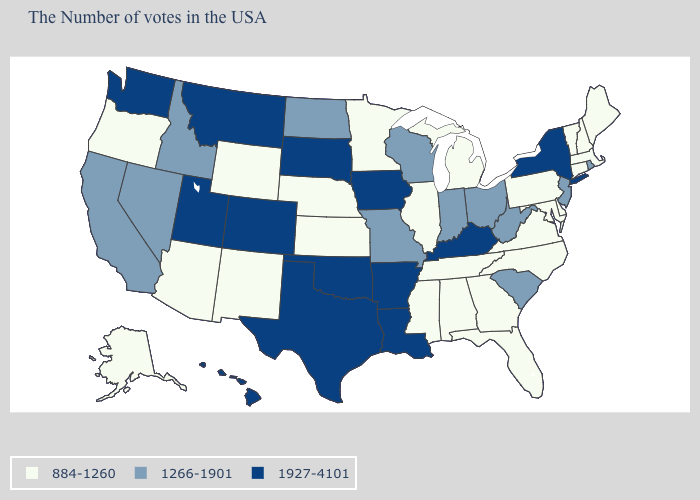Does New York have the lowest value in the Northeast?
Keep it brief. No. What is the value of Vermont?
Quick response, please. 884-1260. What is the value of Vermont?
Concise answer only. 884-1260. Is the legend a continuous bar?
Answer briefly. No. Among the states that border Nevada , which have the highest value?
Keep it brief. Utah. Which states have the highest value in the USA?
Keep it brief. New York, Kentucky, Louisiana, Arkansas, Iowa, Oklahoma, Texas, South Dakota, Colorado, Utah, Montana, Washington, Hawaii. What is the value of New Hampshire?
Quick response, please. 884-1260. Name the states that have a value in the range 1927-4101?
Write a very short answer. New York, Kentucky, Louisiana, Arkansas, Iowa, Oklahoma, Texas, South Dakota, Colorado, Utah, Montana, Washington, Hawaii. What is the value of Hawaii?
Short answer required. 1927-4101. Name the states that have a value in the range 884-1260?
Keep it brief. Maine, Massachusetts, New Hampshire, Vermont, Connecticut, Delaware, Maryland, Pennsylvania, Virginia, North Carolina, Florida, Georgia, Michigan, Alabama, Tennessee, Illinois, Mississippi, Minnesota, Kansas, Nebraska, Wyoming, New Mexico, Arizona, Oregon, Alaska. Is the legend a continuous bar?
Answer briefly. No. What is the value of Louisiana?
Answer briefly. 1927-4101. Among the states that border Massachusetts , does Connecticut have the lowest value?
Write a very short answer. Yes. Among the states that border Texas , does Louisiana have the highest value?
Write a very short answer. Yes. Does the first symbol in the legend represent the smallest category?
Be succinct. Yes. 